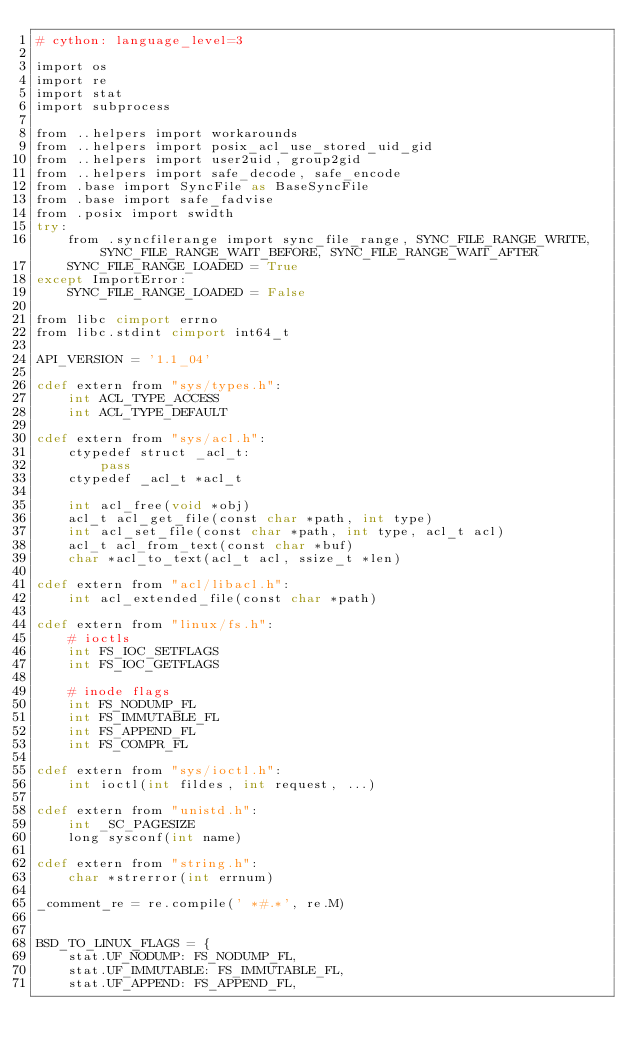Convert code to text. <code><loc_0><loc_0><loc_500><loc_500><_Cython_># cython: language_level=3

import os
import re
import stat
import subprocess

from ..helpers import workarounds
from ..helpers import posix_acl_use_stored_uid_gid
from ..helpers import user2uid, group2gid
from ..helpers import safe_decode, safe_encode
from .base import SyncFile as BaseSyncFile
from .base import safe_fadvise
from .posix import swidth
try:
    from .syncfilerange import sync_file_range, SYNC_FILE_RANGE_WRITE, SYNC_FILE_RANGE_WAIT_BEFORE, SYNC_FILE_RANGE_WAIT_AFTER
    SYNC_FILE_RANGE_LOADED = True
except ImportError:
    SYNC_FILE_RANGE_LOADED = False

from libc cimport errno
from libc.stdint cimport int64_t

API_VERSION = '1.1_04'

cdef extern from "sys/types.h":
    int ACL_TYPE_ACCESS
    int ACL_TYPE_DEFAULT

cdef extern from "sys/acl.h":
    ctypedef struct _acl_t:
        pass
    ctypedef _acl_t *acl_t

    int acl_free(void *obj)
    acl_t acl_get_file(const char *path, int type)
    int acl_set_file(const char *path, int type, acl_t acl)
    acl_t acl_from_text(const char *buf)
    char *acl_to_text(acl_t acl, ssize_t *len)

cdef extern from "acl/libacl.h":
    int acl_extended_file(const char *path)

cdef extern from "linux/fs.h":
    # ioctls
    int FS_IOC_SETFLAGS
    int FS_IOC_GETFLAGS

    # inode flags
    int FS_NODUMP_FL
    int FS_IMMUTABLE_FL
    int FS_APPEND_FL
    int FS_COMPR_FL

cdef extern from "sys/ioctl.h":
    int ioctl(int fildes, int request, ...)

cdef extern from "unistd.h":
    int _SC_PAGESIZE
    long sysconf(int name)

cdef extern from "string.h":
    char *strerror(int errnum)

_comment_re = re.compile(' *#.*', re.M)


BSD_TO_LINUX_FLAGS = {
    stat.UF_NODUMP: FS_NODUMP_FL,
    stat.UF_IMMUTABLE: FS_IMMUTABLE_FL,
    stat.UF_APPEND: FS_APPEND_FL,</code> 